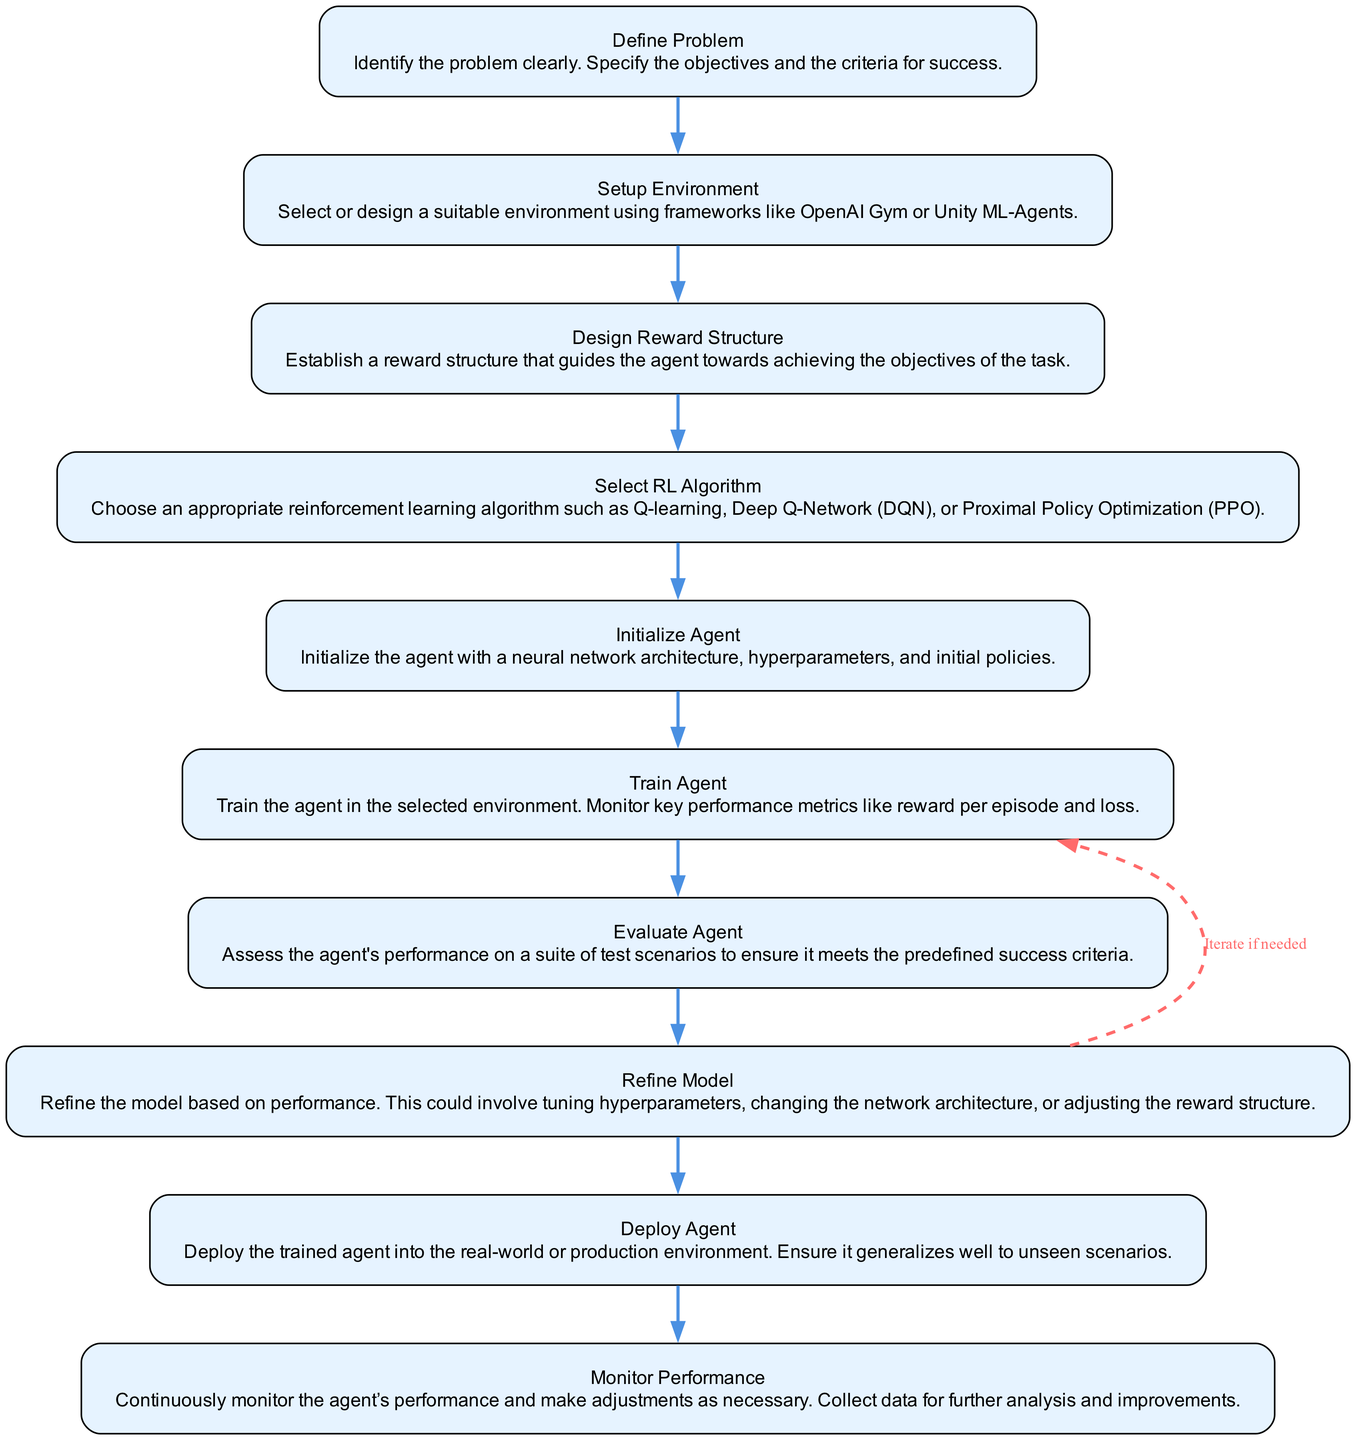What is the first step in developing a reinforcement learning agent? The first step, as indicated by the flowchart, is to "Define Problem," where the problem is identified and objectives are specified.
Answer: Define Problem How many nodes are in the flowchart? The flowchart consists of ten nodes, as there are ten defined actions from environment setup to agent evaluation.
Answer: 10 What action follows "Setup Environment"? According to the flowchart, the action that follows "Setup Environment" is "Design Reward Structure."
Answer: Design Reward Structure Which node does "Refine Model" connect back to? "Refine Model" connects back to "Train Agent," hinting at an iterative process in training to improve the model's performance.
Answer: Train Agent Which reinforcement learning algorithm is mentioned in the flowchart? The flowchart mentions several algorithms, including Q-learning, Deep Q-Network, and Proximal Policy Optimization, but does not specify any one of them as "the" algorithm.
Answer: Q-learning, Deep Q-Network (DQN), Proximal Policy Optimization What is assessed in the "Evaluate Agent" step? In the "Evaluate Agent" step, the performance of the agent is assessed on test scenarios to verify it meets predefined success criteria.
Answer: Agent's performance In which step do you initialize the agent? The agent is initialized in the step labeled "Initialize Agent," where the neural network architecture and hyperparameters are set.
Answer: Initialize Agent What does the dashed edge from "Refine Model" to "Train Agent" signify? The dashed edge signifies an iteration process, indicating that if necessary, the model can be refined before returning to training the agent.
Answer: Iterate if needed Which action involves deploying the agent into the real-world environment? The action that involves deploying the agent into the real-world environment is "Deploy Agent."
Answer: Deploy Agent 